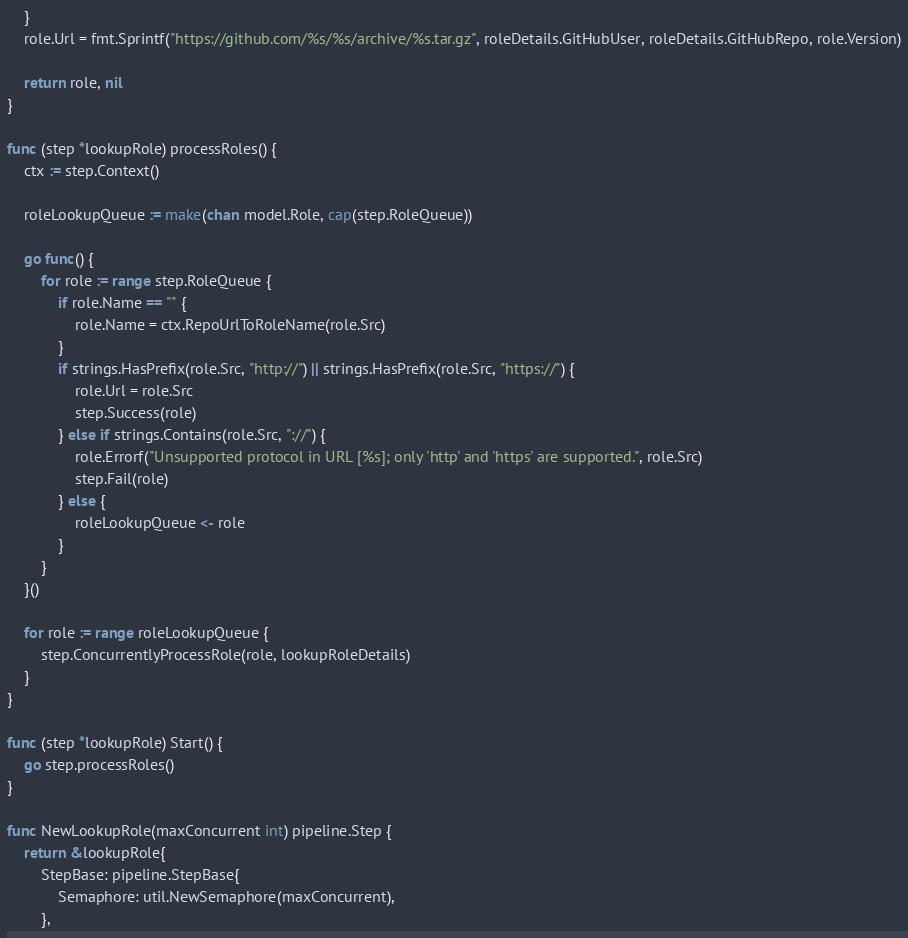Convert code to text. <code><loc_0><loc_0><loc_500><loc_500><_Go_>	}
	role.Url = fmt.Sprintf("https://github.com/%s/%s/archive/%s.tar.gz", roleDetails.GitHubUser, roleDetails.GitHubRepo, role.Version)

	return role, nil
}

func (step *lookupRole) processRoles() {
	ctx := step.Context()

	roleLookupQueue := make(chan model.Role, cap(step.RoleQueue))

	go func() {
		for role := range step.RoleQueue {
			if role.Name == "" {
				role.Name = ctx.RepoUrlToRoleName(role.Src)
			}
			if strings.HasPrefix(role.Src, "http://") || strings.HasPrefix(role.Src, "https://") {
				role.Url = role.Src
				step.Success(role)
			} else if strings.Contains(role.Src, "://") {
				role.Errorf("Unsupported protocol in URL [%s]; only 'http' and 'https' are supported.", role.Src)
				step.Fail(role)
			} else {
				roleLookupQueue <- role
			}
		}
	}()

	for role := range roleLookupQueue {
		step.ConcurrentlyProcessRole(role, lookupRoleDetails)
	}
}

func (step *lookupRole) Start() {
	go step.processRoles()
}

func NewLookupRole(maxConcurrent int) pipeline.Step {
	return &lookupRole{
		StepBase: pipeline.StepBase{
			Semaphore: util.NewSemaphore(maxConcurrent),
		},</code> 